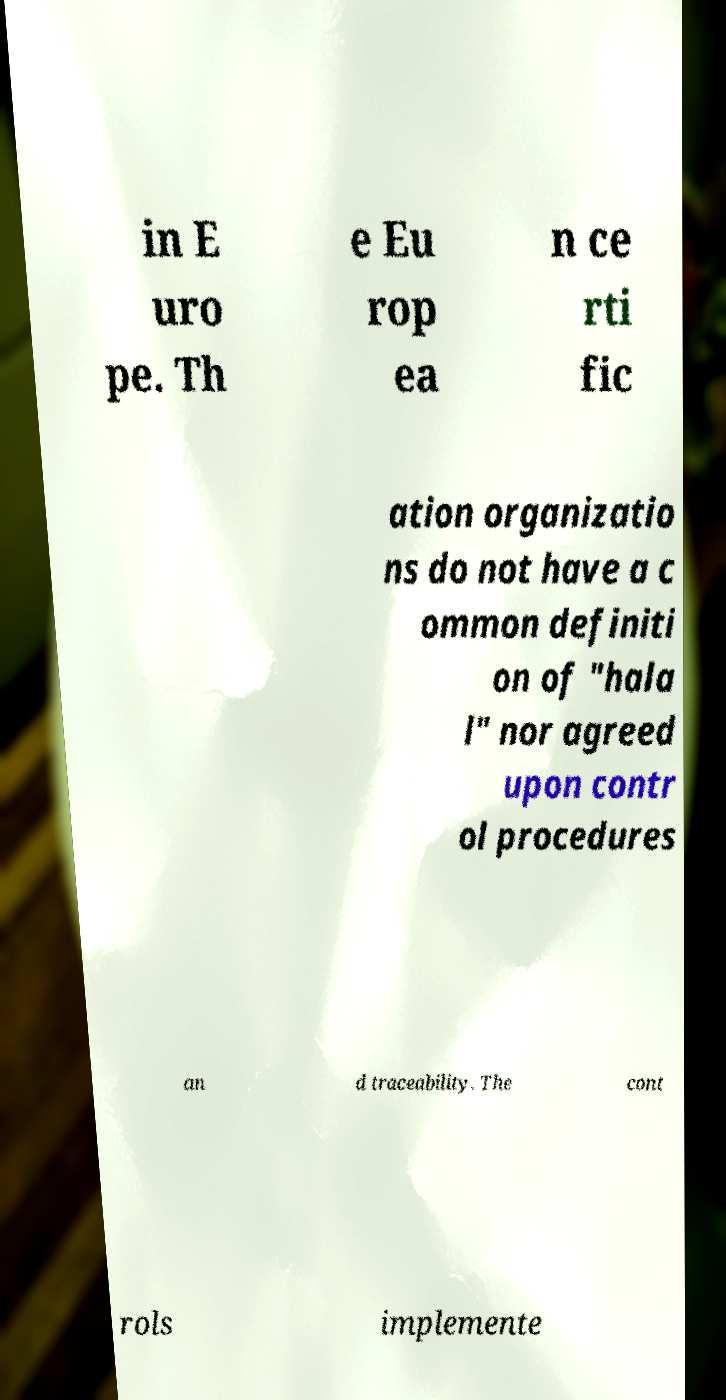Could you assist in decoding the text presented in this image and type it out clearly? in E uro pe. Th e Eu rop ea n ce rti fic ation organizatio ns do not have a c ommon definiti on of "hala l" nor agreed upon contr ol procedures an d traceability. The cont rols implemente 